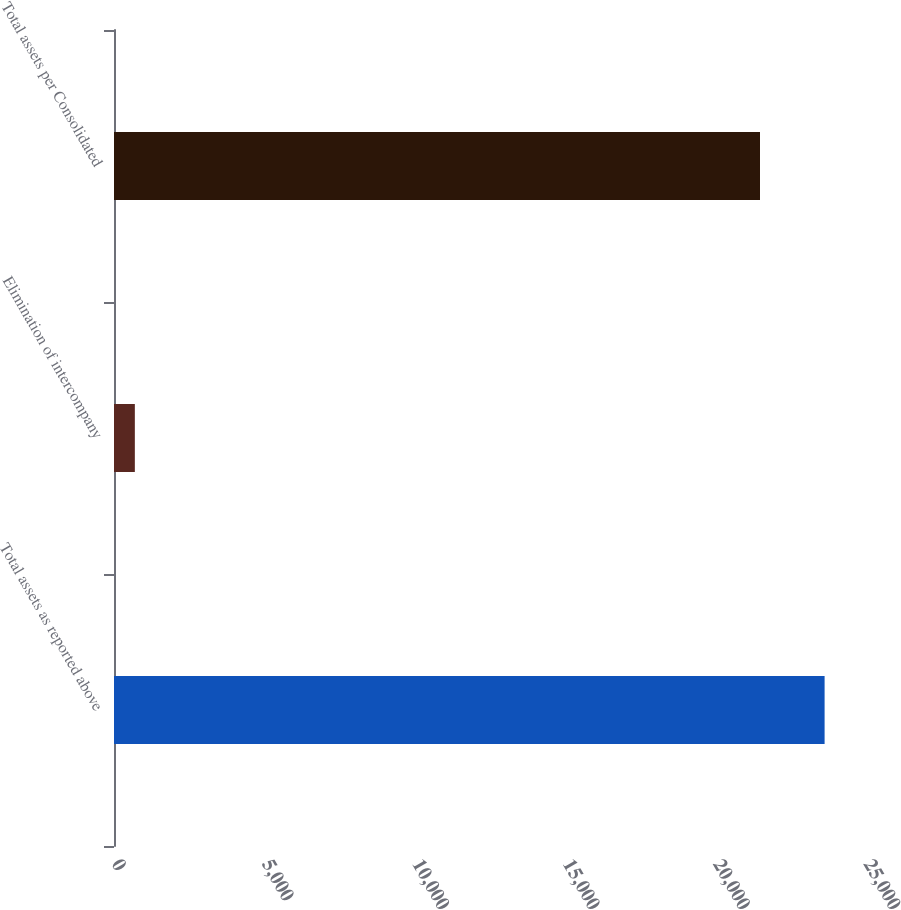Convert chart to OTSL. <chart><loc_0><loc_0><loc_500><loc_500><bar_chart><fcel>Total assets as reported above<fcel>Elimination of intercompany<fcel>Total assets per Consolidated<nl><fcel>23623.6<fcel>693<fcel>21476<nl></chart> 